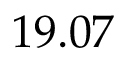<formula> <loc_0><loc_0><loc_500><loc_500>1 9 . 0 7</formula> 